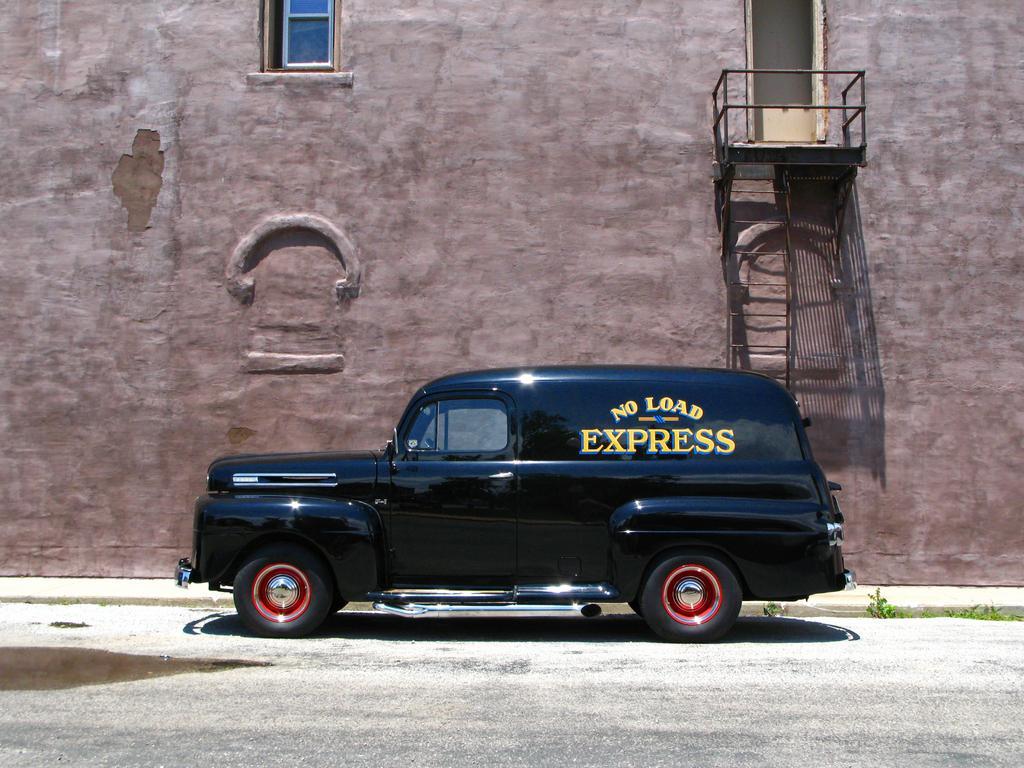Describe this image in one or two sentences. In this image we can see the black color car parked on the road. In the background, we can see the building wall with the window, door and stairs. We can also see the small plants. 